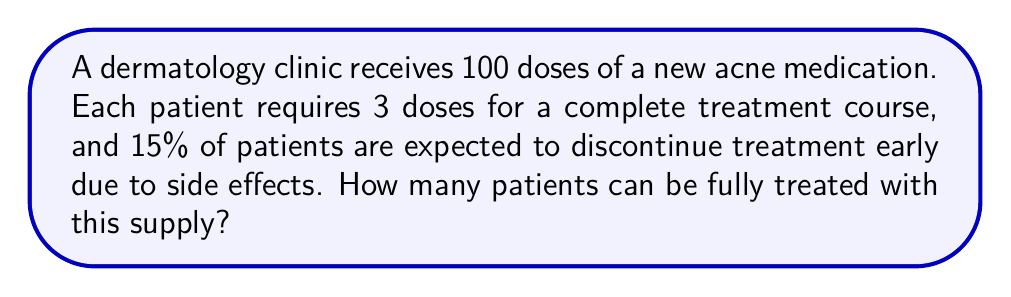Can you solve this math problem? Let's approach this step-by-step:

1) First, we need to calculate the number of doses available for complete treatments:
   - Total doses: 100
   - Doses per patient for complete treatment: 3

2) If all patients completed the treatment, we could treat:
   $$ \frac{100 \text{ doses}}{3 \text{ doses per patient}} = 33.33 \text{ patients} $$

3) However, 15% of patients are expected to discontinue early. This means 85% will complete the treatment.

4) Let $x$ be the number of patients we can start treating. Then:
   - $0.85x$ patients will complete the treatment
   - $0.15x$ patients will discontinue early, using only 1 dose each

5) We can set up an equation:
   $$ 3(0.85x) + 1(0.15x) = 100 $$

6) Simplify:
   $$ 2.55x + 0.15x = 100 $$
   $$ 2.7x = 100 $$

7) Solve for $x$:
   $$ x = \frac{100}{2.7} \approx 37.04 $$

8) Since we can't treat a fraction of a patient, we round down to 37.
Answer: 37 patients 